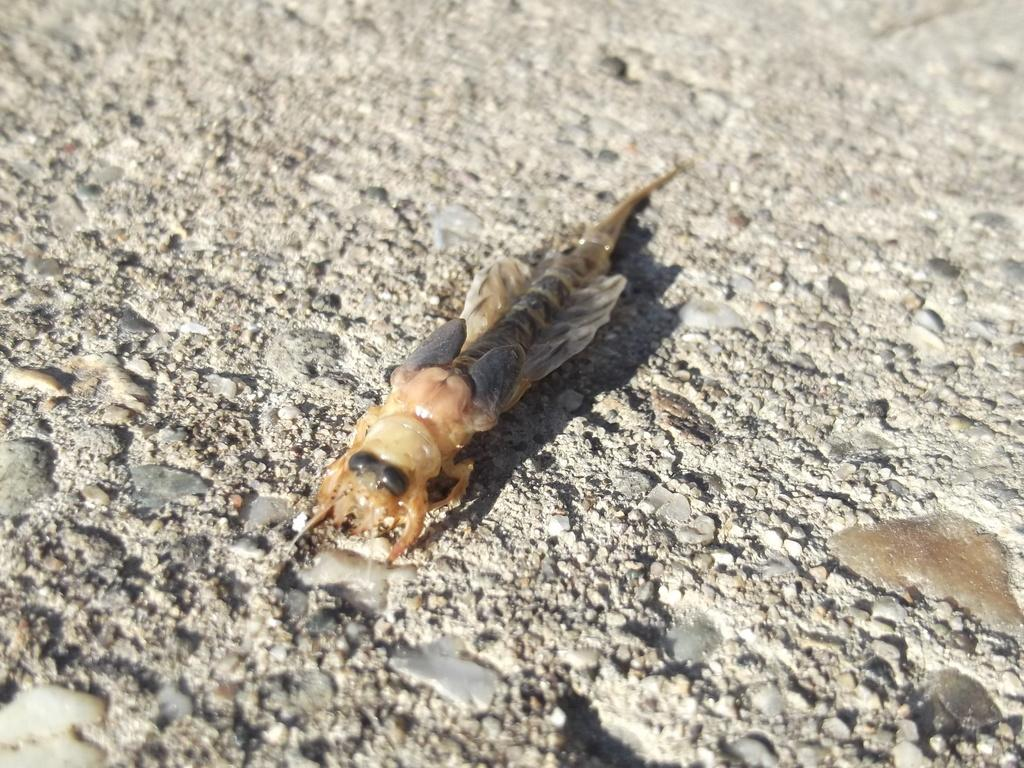What type of creature can be seen in the image? There is an insect present in the image. Where is the insect located in relation to the ground? The insect is on a ground surface. How is the insect positioned within the image? The insect is located in the middle of the image. What type of control does the insect have over the slope in the image? There is no slope present in the image, and the insect does not have any control over it. 